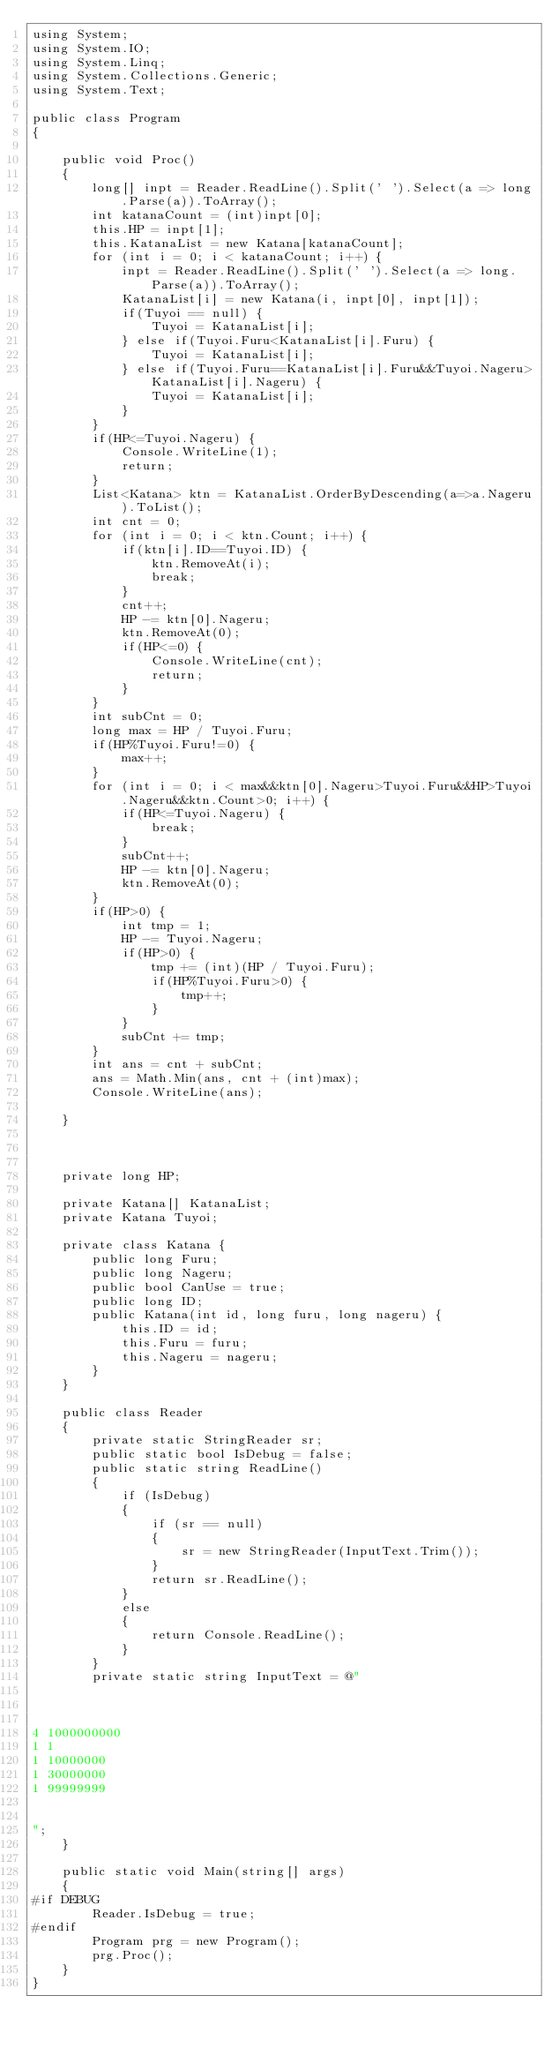Convert code to text. <code><loc_0><loc_0><loc_500><loc_500><_C#_>using System;
using System.IO;
using System.Linq;
using System.Collections.Generic;
using System.Text;

public class Program
{

    public void Proc()
    {
        long[] inpt = Reader.ReadLine().Split(' ').Select(a => long.Parse(a)).ToArray();
        int katanaCount = (int)inpt[0];
        this.HP = inpt[1];
        this.KatanaList = new Katana[katanaCount];
        for (int i = 0; i < katanaCount; i++) {
            inpt = Reader.ReadLine().Split(' ').Select(a => long.Parse(a)).ToArray();
            KatanaList[i] = new Katana(i, inpt[0], inpt[1]);
            if(Tuyoi == null) {
                Tuyoi = KatanaList[i];
            } else if(Tuyoi.Furu<KatanaList[i].Furu) {
                Tuyoi = KatanaList[i];
            } else if(Tuyoi.Furu==KatanaList[i].Furu&&Tuyoi.Nageru>KatanaList[i].Nageru) {
                Tuyoi = KatanaList[i];
            }
        }
        if(HP<=Tuyoi.Nageru) {
            Console.WriteLine(1);
            return;
        }
        List<Katana> ktn = KatanaList.OrderByDescending(a=>a.Nageru).ToList();
        int cnt = 0;
        for (int i = 0; i < ktn.Count; i++) {
            if(ktn[i].ID==Tuyoi.ID) {
                ktn.RemoveAt(i);
                break;
            }
            cnt++;
            HP -= ktn[0].Nageru;
            ktn.RemoveAt(0);
            if(HP<=0) {
                Console.WriteLine(cnt);
                return;
            }
        }
        int subCnt = 0;
        long max = HP / Tuyoi.Furu;
        if(HP%Tuyoi.Furu!=0) {
            max++;
        }
        for (int i = 0; i < max&&ktn[0].Nageru>Tuyoi.Furu&&HP>Tuyoi.Nageru&&ktn.Count>0; i++) {
            if(HP<=Tuyoi.Nageru) {
                break;
            }
            subCnt++;
            HP -= ktn[0].Nageru;
            ktn.RemoveAt(0);
        }
        if(HP>0) {
            int tmp = 1;
            HP -= Tuyoi.Nageru;
            if(HP>0) {
                tmp += (int)(HP / Tuyoi.Furu);
                if(HP%Tuyoi.Furu>0) {
                    tmp++;
                }
            }
            subCnt += tmp;
        }
        int ans = cnt + subCnt;
        ans = Math.Min(ans, cnt + (int)max);
        Console.WriteLine(ans);

    }



    private long HP;

    private Katana[] KatanaList;
    private Katana Tuyoi;

    private class Katana {
        public long Furu;
        public long Nageru;
        public bool CanUse = true;
        public long ID;
        public Katana(int id, long furu, long nageru) {
            this.ID = id;
            this.Furu = furu;
            this.Nageru = nageru;
        }
    }

    public class Reader
    {
        private static StringReader sr;
        public static bool IsDebug = false;
        public static string ReadLine()
        {
            if (IsDebug)
            {
                if (sr == null)
                {
                    sr = new StringReader(InputText.Trim());
                }
                return sr.ReadLine();
            }
            else
            {
                return Console.ReadLine();
            }
        }
        private static string InputText = @"



4 1000000000
1 1
1 10000000
1 30000000
1 99999999


";
    }

    public static void Main(string[] args)
    {
#if DEBUG
        Reader.IsDebug = true;
#endif
        Program prg = new Program();
        prg.Proc();
    }
}
</code> 